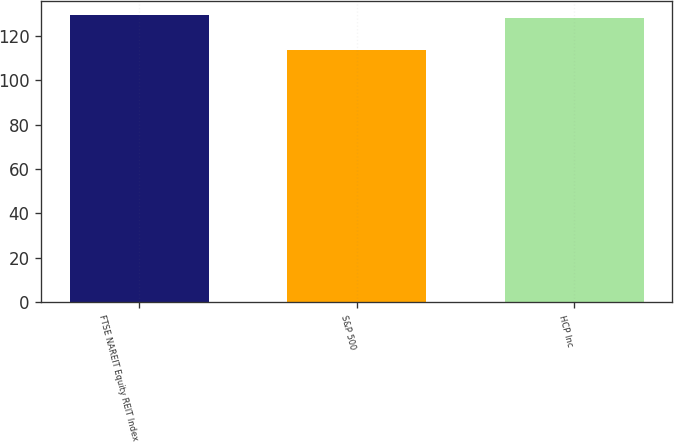Convert chart. <chart><loc_0><loc_0><loc_500><loc_500><bar_chart><fcel>FTSE NAREIT Equity REIT Index<fcel>S&P 500<fcel>HCP Inc<nl><fcel>129.23<fcel>113.68<fcel>127.8<nl></chart> 